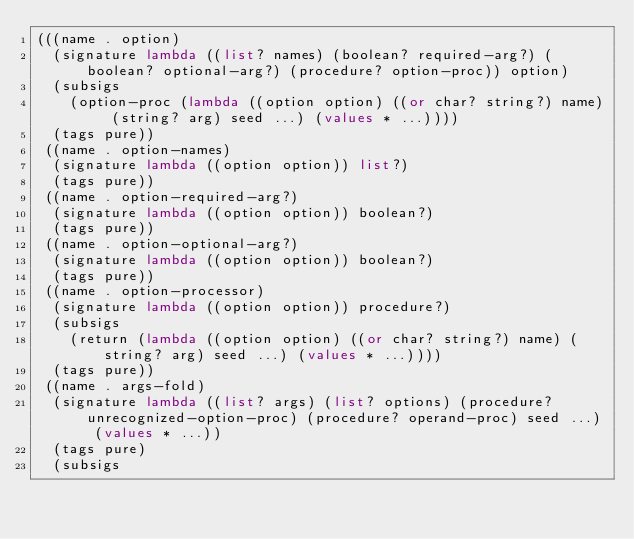Convert code to text. <code><loc_0><loc_0><loc_500><loc_500><_Scheme_>(((name . option)
  (signature lambda ((list? names) (boolean? required-arg?) (boolean? optional-arg?) (procedure? option-proc)) option)
  (subsigs
    (option-proc (lambda ((option option) ((or char? string?) name) (string? arg) seed ...) (values * ...))))
  (tags pure))
 ((name . option-names)
  (signature lambda ((option option)) list?)
  (tags pure))
 ((name . option-required-arg?)
  (signature lambda ((option option)) boolean?)
  (tags pure))
 ((name . option-optional-arg?)
  (signature lambda ((option option)) boolean?)
  (tags pure))
 ((name . option-processor)
  (signature lambda ((option option)) procedure?)
  (subsigs
    (return (lambda ((option option) ((or char? string?) name) (string? arg) seed ...) (values * ...))))
  (tags pure))
 ((name . args-fold)
  (signature lambda ((list? args) (list? options) (procedure? unrecognized-option-proc) (procedure? operand-proc) seed ...) (values * ...))
  (tags pure)
  (subsigs</code> 